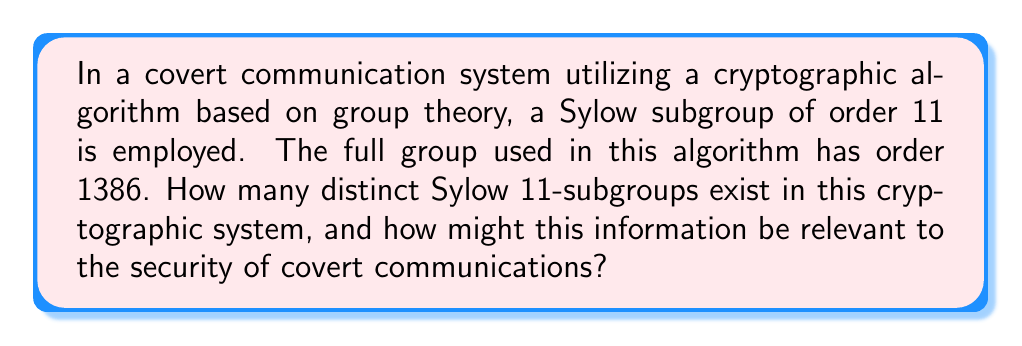Could you help me with this problem? To solve this problem, we'll apply Sylow's theorems, particularly the third theorem, which is crucial in determining the number of Sylow p-subgroups in a finite group.

Let's approach this step-by-step:

1) First, we need to identify the order of the full group and the prime we're interested in:
   - Order of the full group: $|G| = 1386$
   - Prime of interest: $p = 11$

2) We need to factorize 1386:
   $1386 = 2 \times 3^2 \times 7 \times 11$

3) Now, let's apply Sylow's Third Theorem. It states that if $G$ is a finite group and $p$ is a prime dividing the order of $G$, then:
   
   a) The number of Sylow p-subgroups, denoted $n_p$, divides the order of the group divided by $p^k$, where $p^k$ is the highest power of $p$ that divides $|G|$.
   
   b) $n_p \equiv 1 \pmod{p}$

4) In our case:
   - $p = 11$
   - The highest power of 11 dividing 1386 is $11^1 = 11$

5) So, $n_{11}$ must divide $\frac{1386}{11} = 126$

6) The divisors of 126 are: 1, 2, 3, 6, 7, 9, 14, 18, 21, 42, 63, 126

7) Among these, we need to find which ones satisfy $n_{11} \equiv 1 \pmod{11}$

8) The only divisor that satisfies this condition is 1.

Therefore, there is only one Sylow 11-subgroup in this cryptographic system.

Regarding the relevance to the security of covert communications:

The uniqueness of the Sylow 11-subgroup in this system could be both an advantage and a potential vulnerability. On one hand, it simplifies certain computations and can make the system more efficient. On the other hand, if an adversary can identify and exploit this unique subgroup, it might lead to weaknesses in the cryptographic algorithm. In covert communications, where security is paramount, understanding these group-theoretic properties is crucial for assessing and enhancing the robustness of the cryptographic system.
Answer: There is 1 distinct Sylow 11-subgroup in this cryptographic system. 